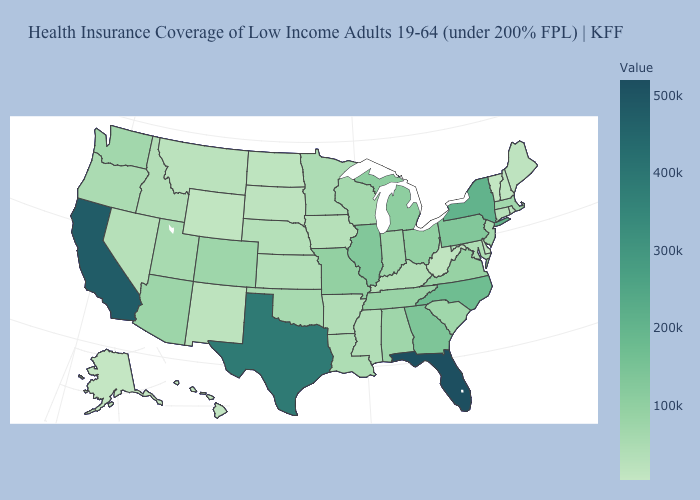Does Nebraska have the lowest value in the USA?
Concise answer only. No. Is the legend a continuous bar?
Answer briefly. Yes. Does Alabama have a higher value than Florida?
Give a very brief answer. No. Among the states that border New York , does Vermont have the lowest value?
Answer briefly. Yes. Among the states that border Missouri , which have the lowest value?
Quick response, please. Iowa. Does the map have missing data?
Short answer required. No. 